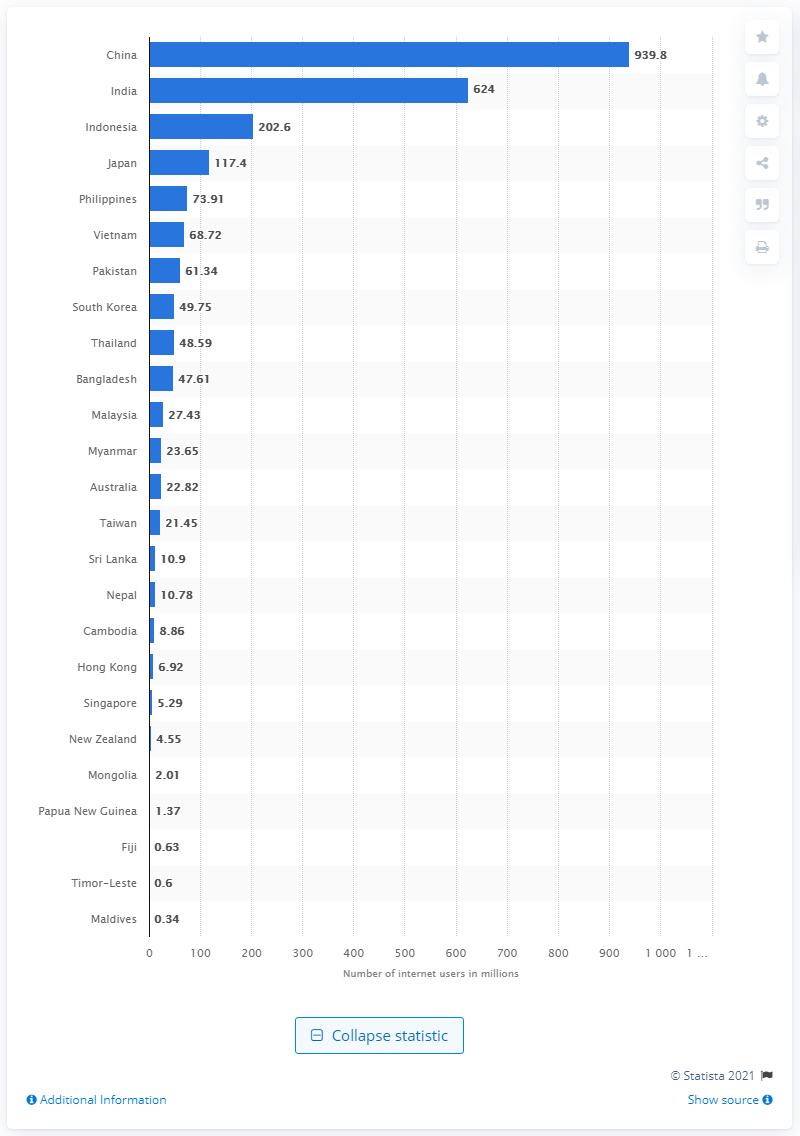Give some essential details in this illustration. As of January 2021, the number of internet users in India was 624 million. As of January 2021, there were approximately 939.8 million internet users in China. 